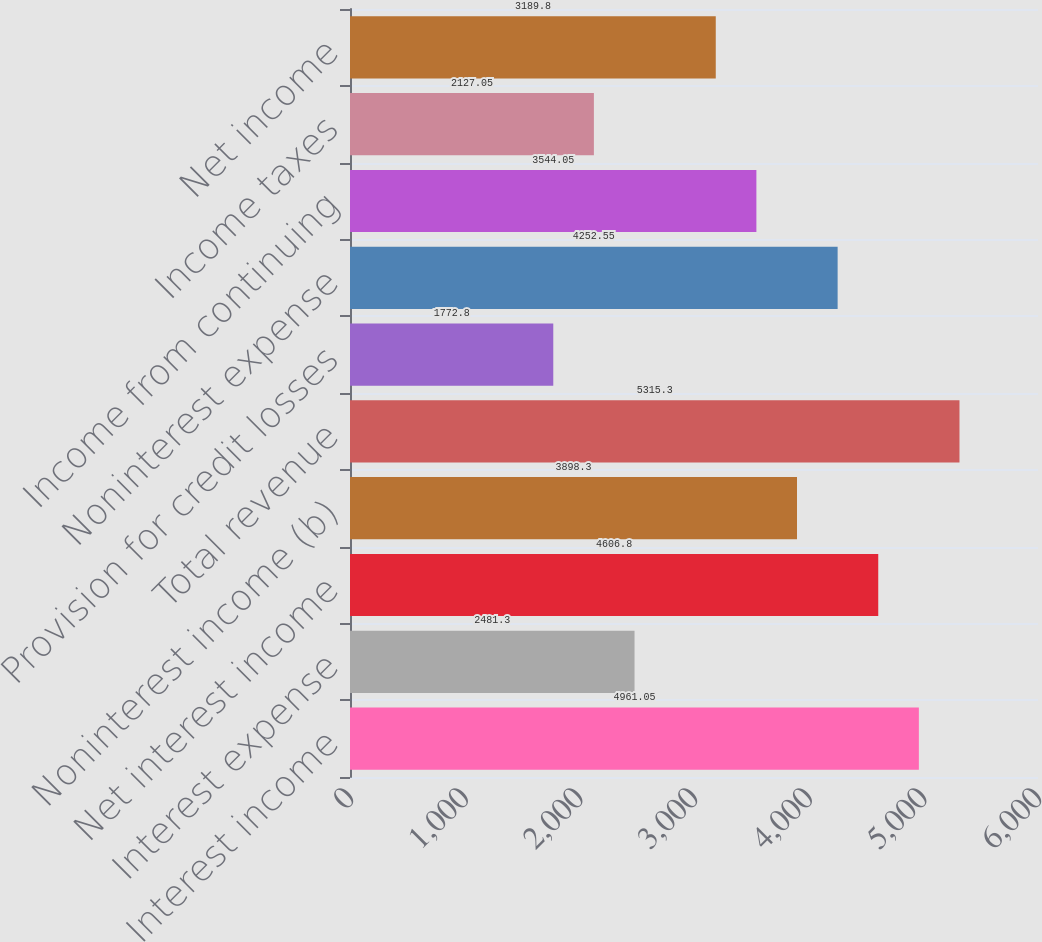Convert chart. <chart><loc_0><loc_0><loc_500><loc_500><bar_chart><fcel>Interest income<fcel>Interest expense<fcel>Net interest income<fcel>Noninterest income (b)<fcel>Total revenue<fcel>Provision for credit losses<fcel>Noninterest expense<fcel>Income from continuing<fcel>Income taxes<fcel>Net income<nl><fcel>4961.05<fcel>2481.3<fcel>4606.8<fcel>3898.3<fcel>5315.3<fcel>1772.8<fcel>4252.55<fcel>3544.05<fcel>2127.05<fcel>3189.8<nl></chart> 